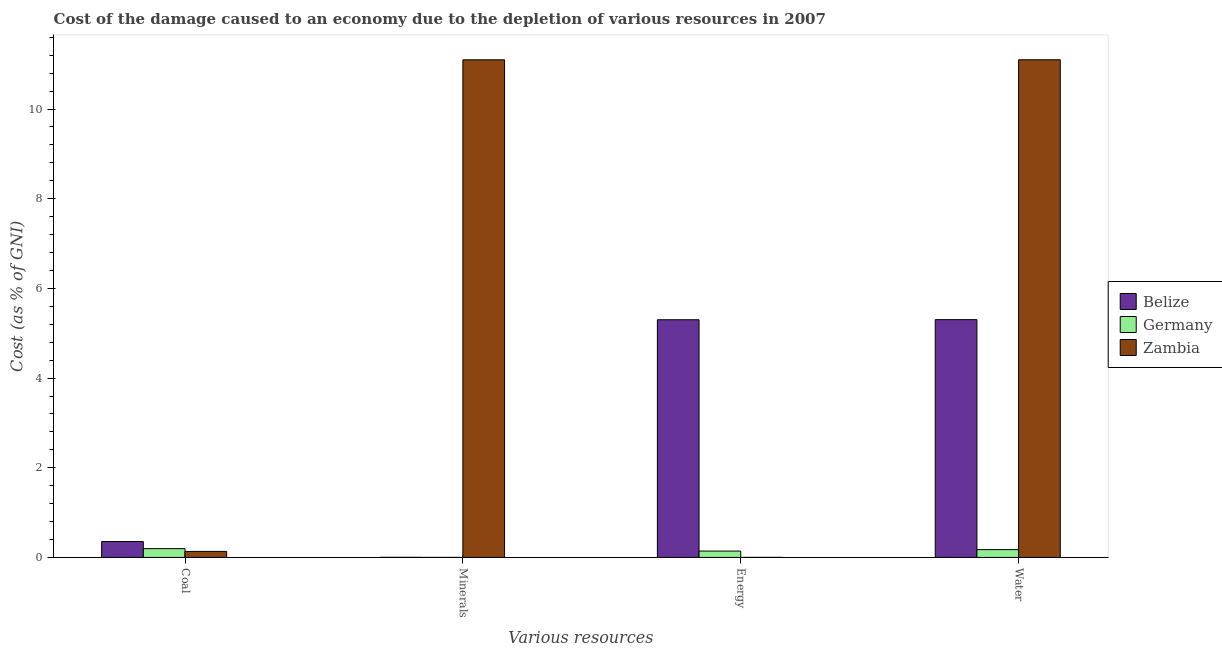How many different coloured bars are there?
Make the answer very short. 3. How many groups of bars are there?
Keep it short and to the point. 4. Are the number of bars per tick equal to the number of legend labels?
Keep it short and to the point. Yes. How many bars are there on the 4th tick from the left?
Make the answer very short. 3. How many bars are there on the 3rd tick from the right?
Your response must be concise. 3. What is the label of the 3rd group of bars from the left?
Provide a succinct answer. Energy. What is the cost of damage due to depletion of water in Zambia?
Your answer should be very brief. 11.1. Across all countries, what is the maximum cost of damage due to depletion of energy?
Give a very brief answer. 5.3. Across all countries, what is the minimum cost of damage due to depletion of water?
Your answer should be very brief. 0.17. In which country was the cost of damage due to depletion of energy maximum?
Your answer should be very brief. Belize. What is the total cost of damage due to depletion of energy in the graph?
Make the answer very short. 5.44. What is the difference between the cost of damage due to depletion of minerals in Germany and that in Belize?
Your answer should be very brief. -0. What is the difference between the cost of damage due to depletion of coal in Belize and the cost of damage due to depletion of water in Germany?
Make the answer very short. 0.18. What is the average cost of damage due to depletion of water per country?
Your answer should be very brief. 5.53. What is the difference between the cost of damage due to depletion of minerals and cost of damage due to depletion of energy in Belize?
Keep it short and to the point. -5.3. In how many countries, is the cost of damage due to depletion of energy greater than 9.2 %?
Provide a succinct answer. 0. What is the ratio of the cost of damage due to depletion of water in Zambia to that in Germany?
Keep it short and to the point. 63.9. What is the difference between the highest and the second highest cost of damage due to depletion of minerals?
Offer a very short reply. 11.1. What is the difference between the highest and the lowest cost of damage due to depletion of energy?
Provide a succinct answer. 5.3. In how many countries, is the cost of damage due to depletion of coal greater than the average cost of damage due to depletion of coal taken over all countries?
Your response must be concise. 1. Is the sum of the cost of damage due to depletion of minerals in Zambia and Belize greater than the maximum cost of damage due to depletion of energy across all countries?
Provide a succinct answer. Yes. Is it the case that in every country, the sum of the cost of damage due to depletion of water and cost of damage due to depletion of energy is greater than the sum of cost of damage due to depletion of coal and cost of damage due to depletion of minerals?
Provide a succinct answer. No. What does the 1st bar from the left in Coal represents?
Provide a short and direct response. Belize. Is it the case that in every country, the sum of the cost of damage due to depletion of coal and cost of damage due to depletion of minerals is greater than the cost of damage due to depletion of energy?
Your answer should be very brief. No. How many bars are there?
Provide a short and direct response. 12. Does the graph contain any zero values?
Give a very brief answer. No. Does the graph contain grids?
Make the answer very short. No. Where does the legend appear in the graph?
Offer a terse response. Center right. How many legend labels are there?
Keep it short and to the point. 3. How are the legend labels stacked?
Offer a terse response. Vertical. What is the title of the graph?
Your response must be concise. Cost of the damage caused to an economy due to the depletion of various resources in 2007 . Does "Tanzania" appear as one of the legend labels in the graph?
Your answer should be very brief. No. What is the label or title of the X-axis?
Offer a very short reply. Various resources. What is the label or title of the Y-axis?
Your response must be concise. Cost (as % of GNI). What is the Cost (as % of GNI) of Belize in Coal?
Your answer should be compact. 0.35. What is the Cost (as % of GNI) of Germany in Coal?
Provide a succinct answer. 0.2. What is the Cost (as % of GNI) in Zambia in Coal?
Give a very brief answer. 0.13. What is the Cost (as % of GNI) of Belize in Minerals?
Make the answer very short. 0. What is the Cost (as % of GNI) in Germany in Minerals?
Keep it short and to the point. 0. What is the Cost (as % of GNI) in Zambia in Minerals?
Provide a succinct answer. 11.1. What is the Cost (as % of GNI) in Belize in Energy?
Make the answer very short. 5.3. What is the Cost (as % of GNI) in Germany in Energy?
Offer a very short reply. 0.14. What is the Cost (as % of GNI) in Zambia in Energy?
Keep it short and to the point. 0. What is the Cost (as % of GNI) of Belize in Water?
Keep it short and to the point. 5.3. What is the Cost (as % of GNI) in Germany in Water?
Offer a very short reply. 0.17. What is the Cost (as % of GNI) in Zambia in Water?
Provide a short and direct response. 11.1. Across all Various resources, what is the maximum Cost (as % of GNI) of Belize?
Ensure brevity in your answer.  5.3. Across all Various resources, what is the maximum Cost (as % of GNI) of Germany?
Your response must be concise. 0.2. Across all Various resources, what is the maximum Cost (as % of GNI) of Zambia?
Keep it short and to the point. 11.1. Across all Various resources, what is the minimum Cost (as % of GNI) in Belize?
Provide a succinct answer. 0. Across all Various resources, what is the minimum Cost (as % of GNI) of Germany?
Provide a short and direct response. 0. Across all Various resources, what is the minimum Cost (as % of GNI) in Zambia?
Provide a succinct answer. 0. What is the total Cost (as % of GNI) in Belize in the graph?
Your answer should be very brief. 10.96. What is the total Cost (as % of GNI) of Germany in the graph?
Keep it short and to the point. 0.51. What is the total Cost (as % of GNI) in Zambia in the graph?
Offer a very short reply. 22.33. What is the difference between the Cost (as % of GNI) in Belize in Coal and that in Minerals?
Your answer should be very brief. 0.35. What is the difference between the Cost (as % of GNI) of Germany in Coal and that in Minerals?
Give a very brief answer. 0.2. What is the difference between the Cost (as % of GNI) of Zambia in Coal and that in Minerals?
Your answer should be very brief. -10.96. What is the difference between the Cost (as % of GNI) of Belize in Coal and that in Energy?
Offer a terse response. -4.95. What is the difference between the Cost (as % of GNI) in Germany in Coal and that in Energy?
Your answer should be very brief. 0.05. What is the difference between the Cost (as % of GNI) of Zambia in Coal and that in Energy?
Your answer should be very brief. 0.13. What is the difference between the Cost (as % of GNI) in Belize in Coal and that in Water?
Provide a short and direct response. -4.95. What is the difference between the Cost (as % of GNI) of Germany in Coal and that in Water?
Offer a terse response. 0.02. What is the difference between the Cost (as % of GNI) in Zambia in Coal and that in Water?
Provide a succinct answer. -10.97. What is the difference between the Cost (as % of GNI) of Belize in Minerals and that in Energy?
Provide a succinct answer. -5.3. What is the difference between the Cost (as % of GNI) of Germany in Minerals and that in Energy?
Your answer should be very brief. -0.14. What is the difference between the Cost (as % of GNI) of Zambia in Minerals and that in Energy?
Offer a terse response. 11.1. What is the difference between the Cost (as % of GNI) of Belize in Minerals and that in Water?
Your answer should be compact. -5.3. What is the difference between the Cost (as % of GNI) in Germany in Minerals and that in Water?
Make the answer very short. -0.17. What is the difference between the Cost (as % of GNI) of Zambia in Minerals and that in Water?
Make the answer very short. -0. What is the difference between the Cost (as % of GNI) in Belize in Energy and that in Water?
Keep it short and to the point. -0. What is the difference between the Cost (as % of GNI) of Germany in Energy and that in Water?
Your answer should be very brief. -0.03. What is the difference between the Cost (as % of GNI) in Zambia in Energy and that in Water?
Your answer should be very brief. -11.1. What is the difference between the Cost (as % of GNI) in Belize in Coal and the Cost (as % of GNI) in Germany in Minerals?
Ensure brevity in your answer.  0.35. What is the difference between the Cost (as % of GNI) of Belize in Coal and the Cost (as % of GNI) of Zambia in Minerals?
Your answer should be very brief. -10.74. What is the difference between the Cost (as % of GNI) in Germany in Coal and the Cost (as % of GNI) in Zambia in Minerals?
Your answer should be compact. -10.9. What is the difference between the Cost (as % of GNI) in Belize in Coal and the Cost (as % of GNI) in Germany in Energy?
Provide a succinct answer. 0.21. What is the difference between the Cost (as % of GNI) in Belize in Coal and the Cost (as % of GNI) in Zambia in Energy?
Ensure brevity in your answer.  0.35. What is the difference between the Cost (as % of GNI) in Germany in Coal and the Cost (as % of GNI) in Zambia in Energy?
Ensure brevity in your answer.  0.19. What is the difference between the Cost (as % of GNI) of Belize in Coal and the Cost (as % of GNI) of Germany in Water?
Make the answer very short. 0.18. What is the difference between the Cost (as % of GNI) in Belize in Coal and the Cost (as % of GNI) in Zambia in Water?
Keep it short and to the point. -10.74. What is the difference between the Cost (as % of GNI) of Germany in Coal and the Cost (as % of GNI) of Zambia in Water?
Give a very brief answer. -10.9. What is the difference between the Cost (as % of GNI) of Belize in Minerals and the Cost (as % of GNI) of Germany in Energy?
Provide a short and direct response. -0.14. What is the difference between the Cost (as % of GNI) in Germany in Minerals and the Cost (as % of GNI) in Zambia in Energy?
Keep it short and to the point. -0. What is the difference between the Cost (as % of GNI) in Belize in Minerals and the Cost (as % of GNI) in Germany in Water?
Your answer should be very brief. -0.17. What is the difference between the Cost (as % of GNI) of Belize in Minerals and the Cost (as % of GNI) of Zambia in Water?
Give a very brief answer. -11.1. What is the difference between the Cost (as % of GNI) in Germany in Minerals and the Cost (as % of GNI) in Zambia in Water?
Ensure brevity in your answer.  -11.1. What is the difference between the Cost (as % of GNI) in Belize in Energy and the Cost (as % of GNI) in Germany in Water?
Keep it short and to the point. 5.13. What is the difference between the Cost (as % of GNI) of Belize in Energy and the Cost (as % of GNI) of Zambia in Water?
Make the answer very short. -5.8. What is the difference between the Cost (as % of GNI) in Germany in Energy and the Cost (as % of GNI) in Zambia in Water?
Your answer should be compact. -10.96. What is the average Cost (as % of GNI) in Belize per Various resources?
Your answer should be very brief. 2.74. What is the average Cost (as % of GNI) of Germany per Various resources?
Keep it short and to the point. 0.13. What is the average Cost (as % of GNI) in Zambia per Various resources?
Your answer should be compact. 5.58. What is the difference between the Cost (as % of GNI) of Belize and Cost (as % of GNI) of Germany in Coal?
Your answer should be very brief. 0.16. What is the difference between the Cost (as % of GNI) in Belize and Cost (as % of GNI) in Zambia in Coal?
Your answer should be compact. 0.22. What is the difference between the Cost (as % of GNI) of Germany and Cost (as % of GNI) of Zambia in Coal?
Keep it short and to the point. 0.06. What is the difference between the Cost (as % of GNI) in Belize and Cost (as % of GNI) in Germany in Minerals?
Offer a very short reply. 0. What is the difference between the Cost (as % of GNI) in Belize and Cost (as % of GNI) in Zambia in Minerals?
Your answer should be very brief. -11.1. What is the difference between the Cost (as % of GNI) of Germany and Cost (as % of GNI) of Zambia in Minerals?
Keep it short and to the point. -11.1. What is the difference between the Cost (as % of GNI) in Belize and Cost (as % of GNI) in Germany in Energy?
Offer a very short reply. 5.16. What is the difference between the Cost (as % of GNI) of Belize and Cost (as % of GNI) of Zambia in Energy?
Your response must be concise. 5.3. What is the difference between the Cost (as % of GNI) in Germany and Cost (as % of GNI) in Zambia in Energy?
Offer a terse response. 0.14. What is the difference between the Cost (as % of GNI) in Belize and Cost (as % of GNI) in Germany in Water?
Your response must be concise. 5.13. What is the difference between the Cost (as % of GNI) of Belize and Cost (as % of GNI) of Zambia in Water?
Provide a short and direct response. -5.8. What is the difference between the Cost (as % of GNI) of Germany and Cost (as % of GNI) of Zambia in Water?
Your response must be concise. -10.93. What is the ratio of the Cost (as % of GNI) of Belize in Coal to that in Minerals?
Ensure brevity in your answer.  152.62. What is the ratio of the Cost (as % of GNI) in Germany in Coal to that in Minerals?
Offer a terse response. 446.76. What is the ratio of the Cost (as % of GNI) in Zambia in Coal to that in Minerals?
Keep it short and to the point. 0.01. What is the ratio of the Cost (as % of GNI) of Belize in Coal to that in Energy?
Make the answer very short. 0.07. What is the ratio of the Cost (as % of GNI) of Germany in Coal to that in Energy?
Provide a short and direct response. 1.38. What is the ratio of the Cost (as % of GNI) of Zambia in Coal to that in Energy?
Offer a very short reply. 104.14. What is the ratio of the Cost (as % of GNI) of Belize in Coal to that in Water?
Provide a short and direct response. 0.07. What is the ratio of the Cost (as % of GNI) in Germany in Coal to that in Water?
Ensure brevity in your answer.  1.13. What is the ratio of the Cost (as % of GNI) in Zambia in Coal to that in Water?
Ensure brevity in your answer.  0.01. What is the ratio of the Cost (as % of GNI) of Germany in Minerals to that in Energy?
Offer a very short reply. 0. What is the ratio of the Cost (as % of GNI) in Zambia in Minerals to that in Energy?
Keep it short and to the point. 8625.85. What is the ratio of the Cost (as % of GNI) in Belize in Minerals to that in Water?
Your response must be concise. 0. What is the ratio of the Cost (as % of GNI) in Germany in Minerals to that in Water?
Keep it short and to the point. 0. What is the ratio of the Cost (as % of GNI) of Zambia in Minerals to that in Water?
Keep it short and to the point. 1. What is the ratio of the Cost (as % of GNI) of Belize in Energy to that in Water?
Provide a short and direct response. 1. What is the ratio of the Cost (as % of GNI) of Germany in Energy to that in Water?
Your answer should be very brief. 0.82. What is the ratio of the Cost (as % of GNI) of Zambia in Energy to that in Water?
Keep it short and to the point. 0. What is the difference between the highest and the second highest Cost (as % of GNI) of Belize?
Provide a short and direct response. 0. What is the difference between the highest and the second highest Cost (as % of GNI) in Germany?
Ensure brevity in your answer.  0.02. What is the difference between the highest and the second highest Cost (as % of GNI) of Zambia?
Provide a succinct answer. 0. What is the difference between the highest and the lowest Cost (as % of GNI) in Belize?
Your response must be concise. 5.3. What is the difference between the highest and the lowest Cost (as % of GNI) in Germany?
Offer a terse response. 0.2. What is the difference between the highest and the lowest Cost (as % of GNI) of Zambia?
Make the answer very short. 11.1. 